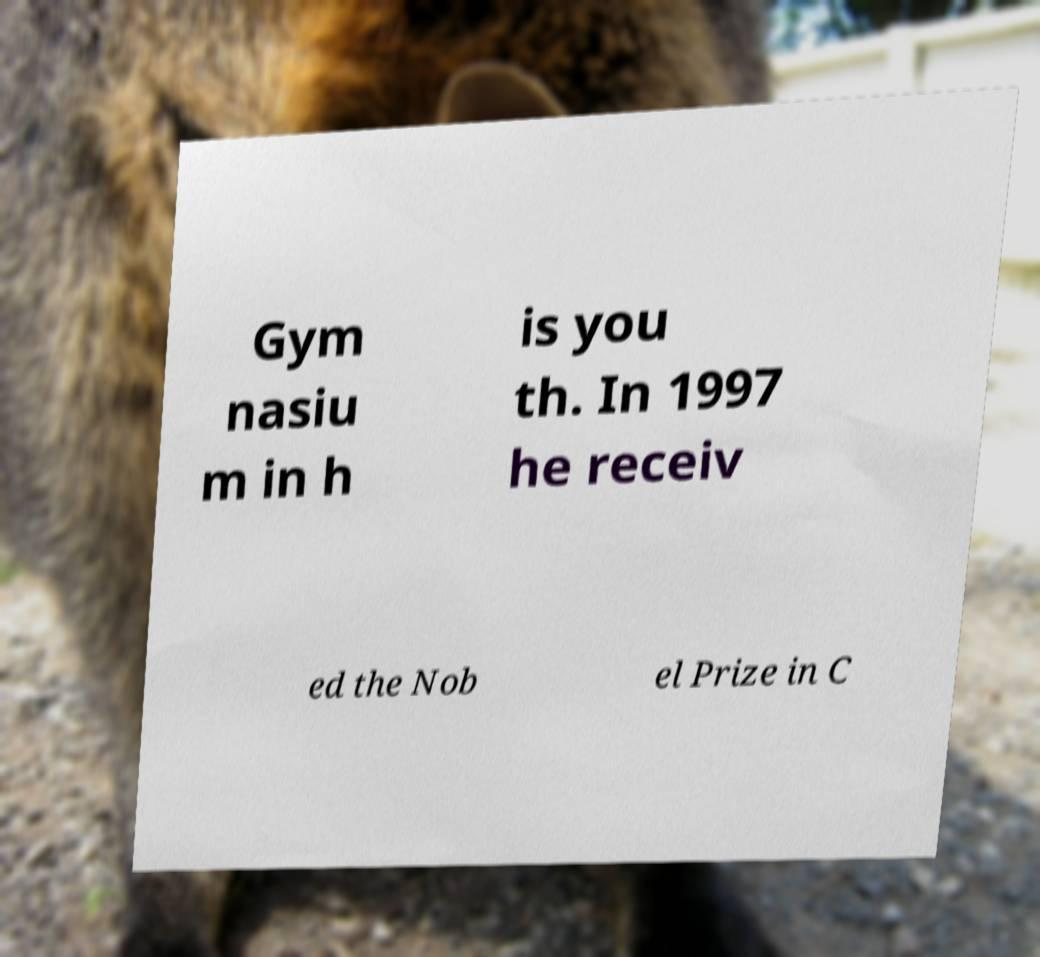Could you assist in decoding the text presented in this image and type it out clearly? Gym nasiu m in h is you th. In 1997 he receiv ed the Nob el Prize in C 